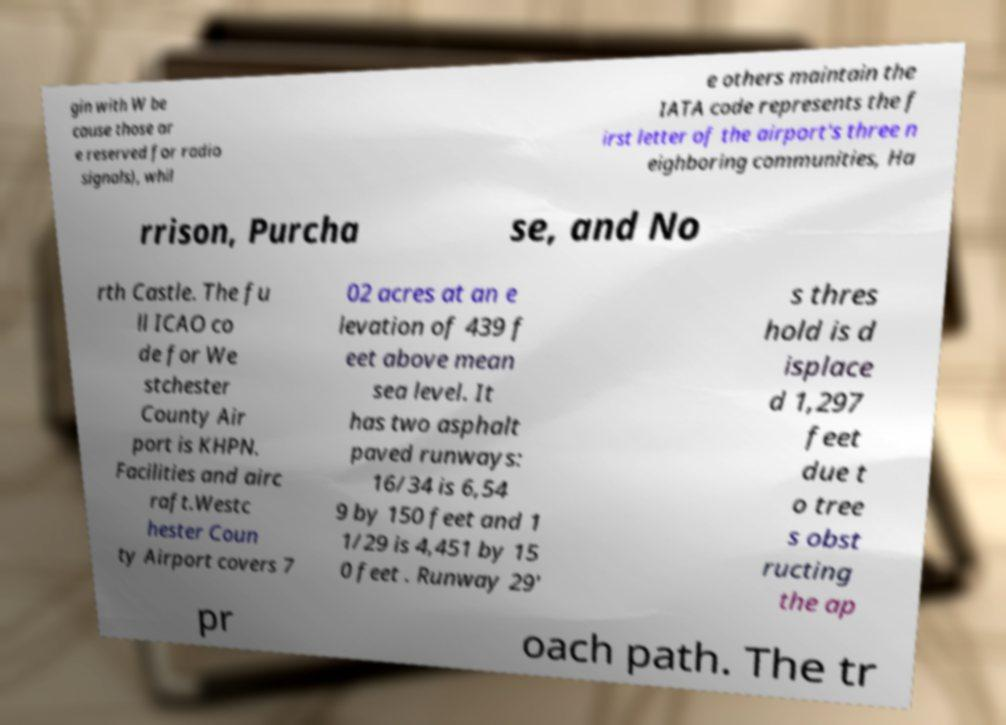Can you accurately transcribe the text from the provided image for me? gin with W be cause those ar e reserved for radio signals), whil e others maintain the IATA code represents the f irst letter of the airport's three n eighboring communities, Ha rrison, Purcha se, and No rth Castle. The fu ll ICAO co de for We stchester County Air port is KHPN. Facilities and airc raft.Westc hester Coun ty Airport covers 7 02 acres at an e levation of 439 f eet above mean sea level. It has two asphalt paved runways: 16/34 is 6,54 9 by 150 feet and 1 1/29 is 4,451 by 15 0 feet . Runway 29' s thres hold is d isplace d 1,297 feet due t o tree s obst ructing the ap pr oach path. The tr 